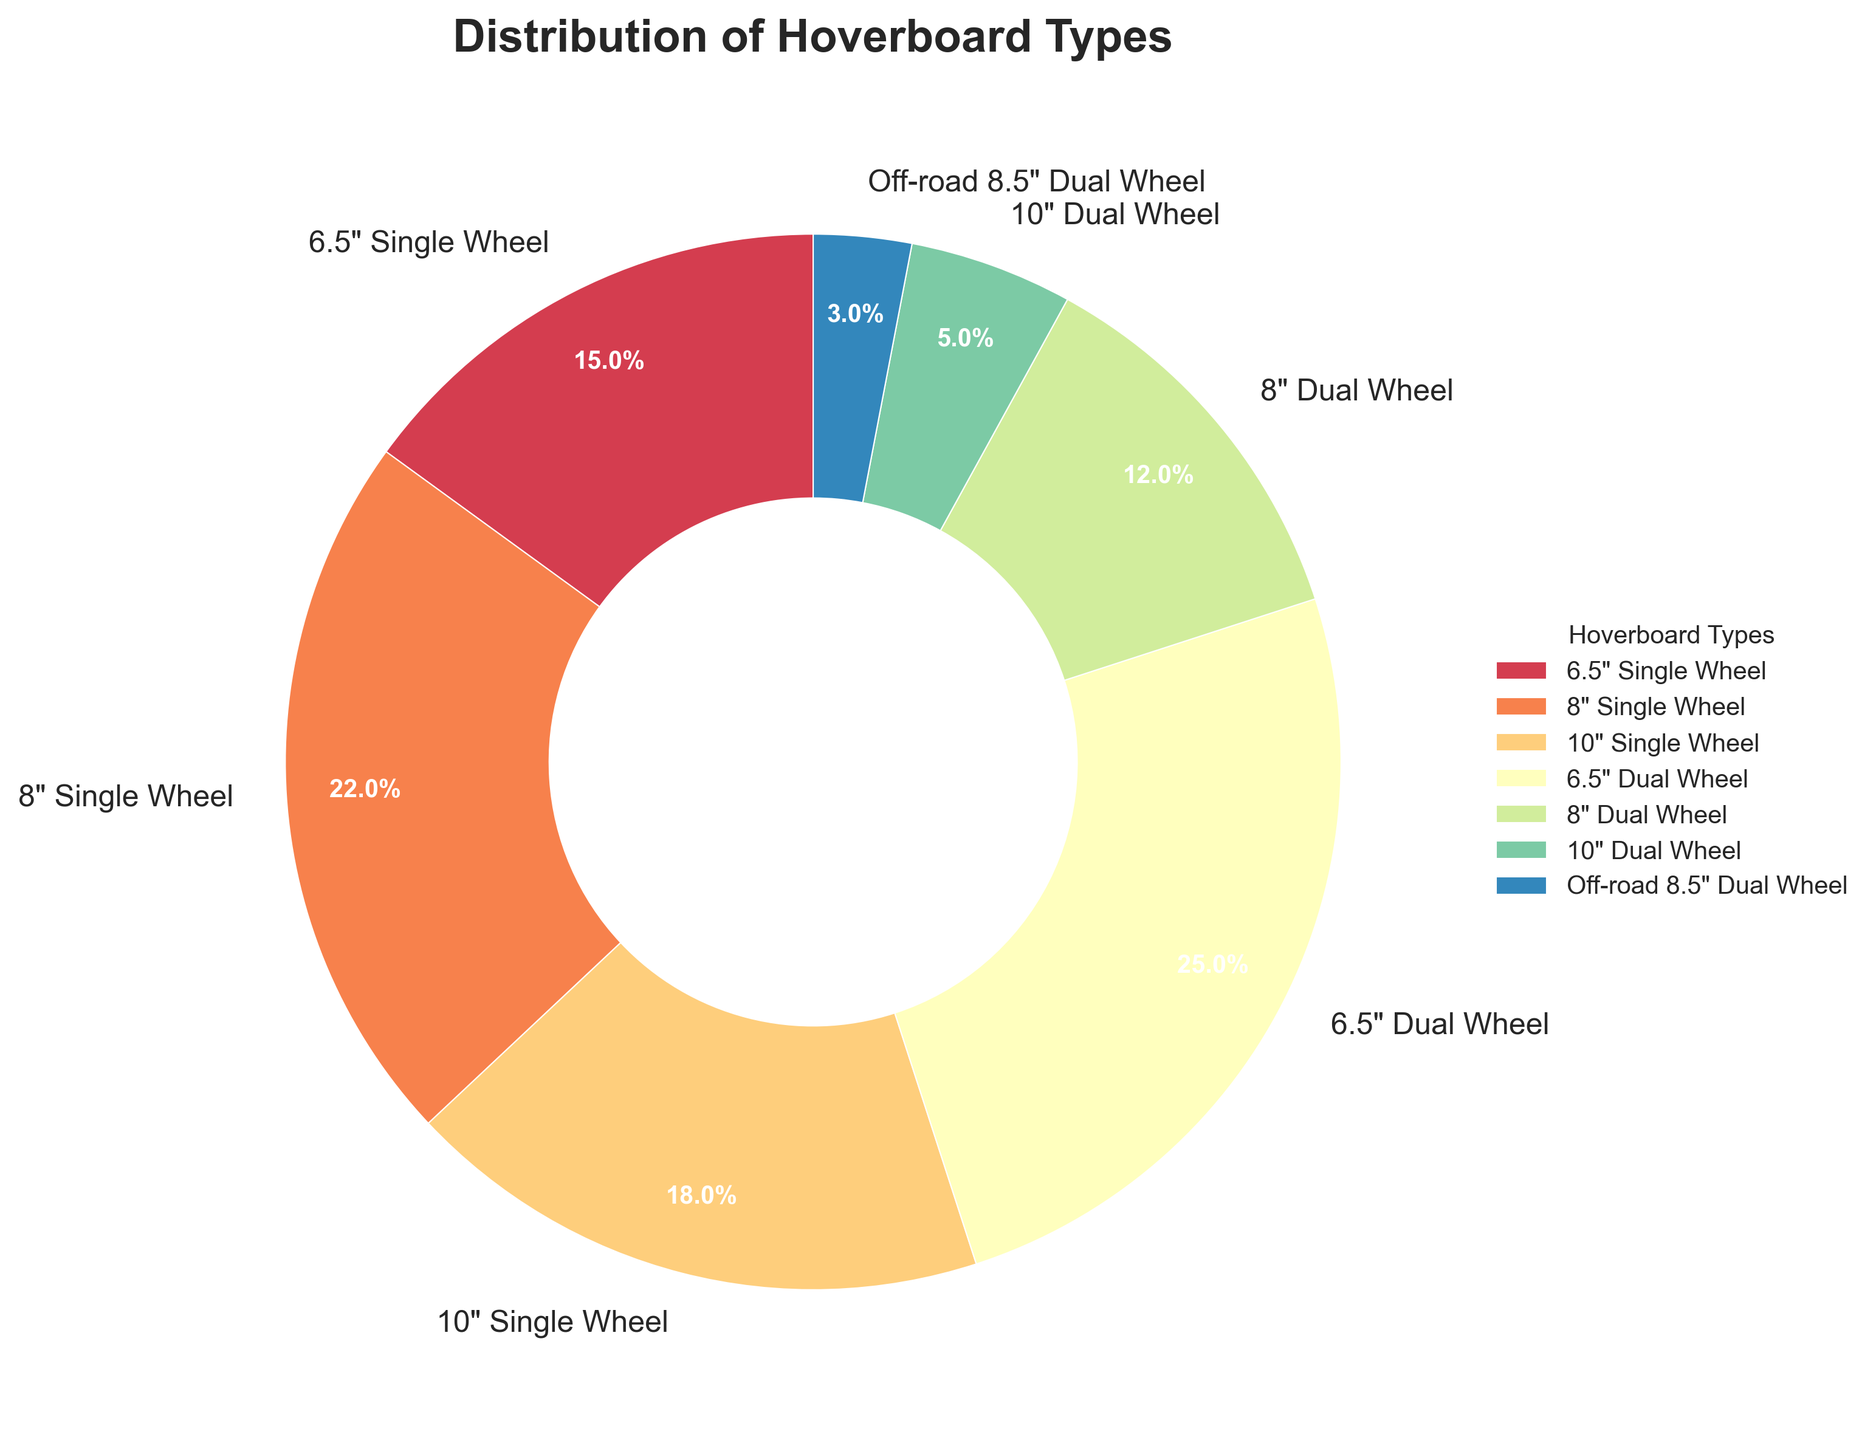Which hoverboard type has the highest percentage distribution? The chart shows different hoverboard types and their respective distribution percentages. The 6.5" Dual Wheel has the highest percentage with 25%.
Answer: 6.5" Dual Wheel What is the combined percentage of all single wheel hoverboards? The chart provides percentages for 6.5" Single Wheel (15%), 8" Single Wheel (22%), and 10" Single Wheel (18%). Adding these together: 15% + 22% + 18% = 55%.
Answer: 55% Which hoverboard type has the lowest percentage distribution? Observing the percentages in the chart, the Off-road 8.5" Dual Wheel has the lowest distribution with 3%.
Answer: Off-road 8.5" Dual Wheel Is the distribution of 8" Dual Wheel more or less than 10" Single Wheel? The chart shows 8" Dual Wheel at 12% and 10" Single Wheel at 18%. Since 12% < 18%, the 8" Dual Wheel has a lower distribution.
Answer: Less Among the dual wheel hoverboards, which type has the smallest percentage? The dual wheel categories are 6.5" Dual Wheel (25%), 8" Dual Wheel (12%), 10" Dual Wheel (5%), and Off-road 8.5" Dual Wheel (3%). The smallest percentage is the Off-road 8.5" Dual Wheel with 3%.
Answer: Off-road 8.5" Dual Wheel What's the difference in percentage distribution between 6.5" Single Wheel and 6.5" Dual Wheel hoverboards? The chart shows 6.5" Single Wheel at 15% and 6.5" Dual Wheel at 25%. The difference is calculated as 25% - 15% = 10%.
Answer: 10% What is the total percentage of all dual wheel hoverboards? The dual wheel categories are 6.5" Dual Wheel (25%), 8" Dual Wheel (12%), 10" Dual Wheel (5%), and Off-road 8.5" Dual Wheel (3%). Adding these gives: 25% + 12% + 5% + 3% = 45%.
Answer: 45% Between single wheel and dual wheel hoverboards, which group has a higher total distribution percentage? Single wheel percentages are 15% (6.5"), 22% (8"), and 18% (10"), summing to 55%. Dual wheel percentages are 25% (6.5"), 12% (8"), 5% (10"), and 3% (Off-road 8.5"), summing to 45%. 55% (single wheel) is greater than 45% (dual wheel).
Answer: Single wheel 